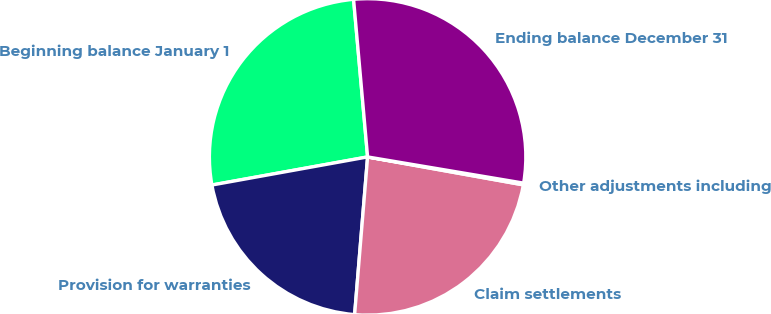Convert chart. <chart><loc_0><loc_0><loc_500><loc_500><pie_chart><fcel>Beginning balance January 1<fcel>Provision for warranties<fcel>Claim settlements<fcel>Other adjustments including<fcel>Ending balance December 31<nl><fcel>26.43%<fcel>20.85%<fcel>23.48%<fcel>0.18%<fcel>29.06%<nl></chart> 